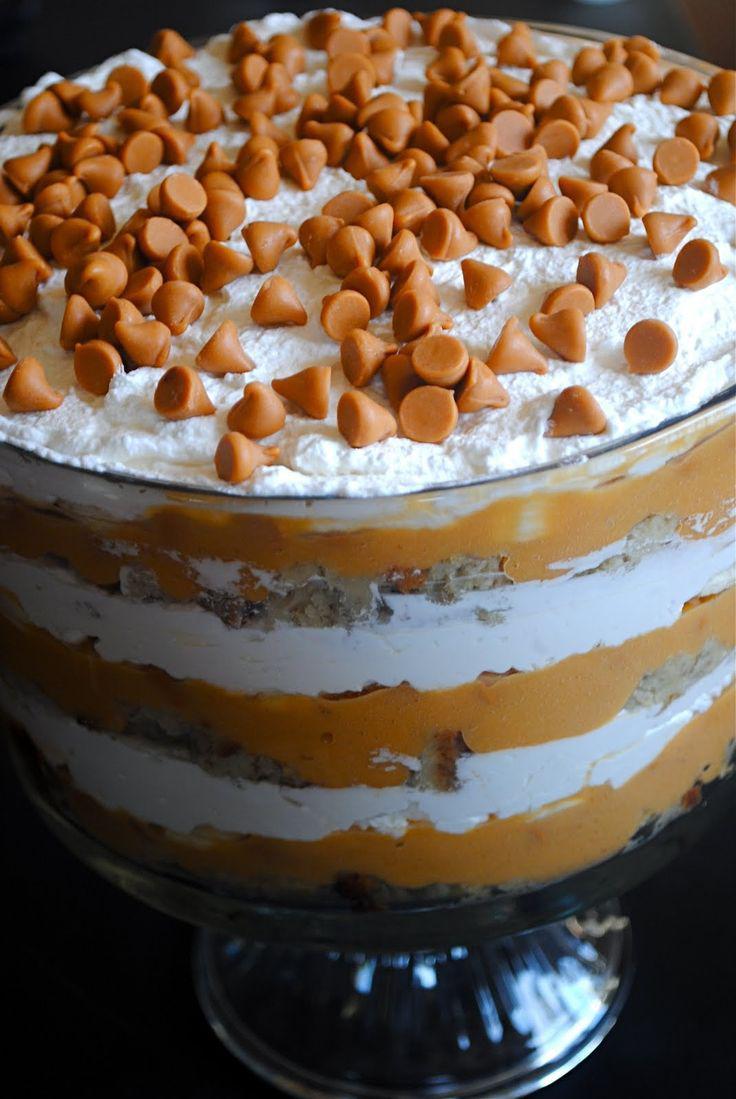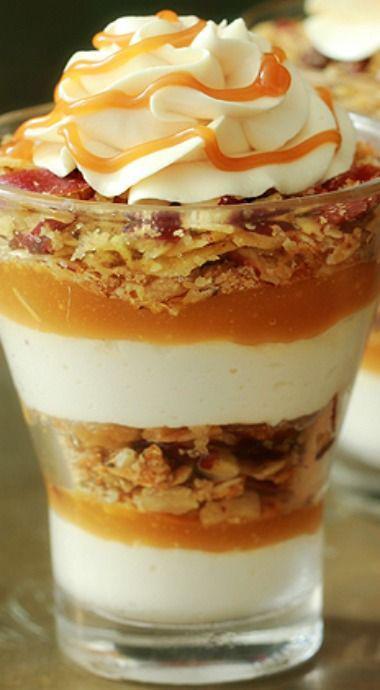The first image is the image on the left, the second image is the image on the right. Given the left and right images, does the statement "One image shows at least one fancy individual serving dessert." hold true? Answer yes or no. Yes. The first image is the image on the left, the second image is the image on the right. Given the left and right images, does the statement "There are two chocolate parfait and two non chocolate" hold true? Answer yes or no. No. 